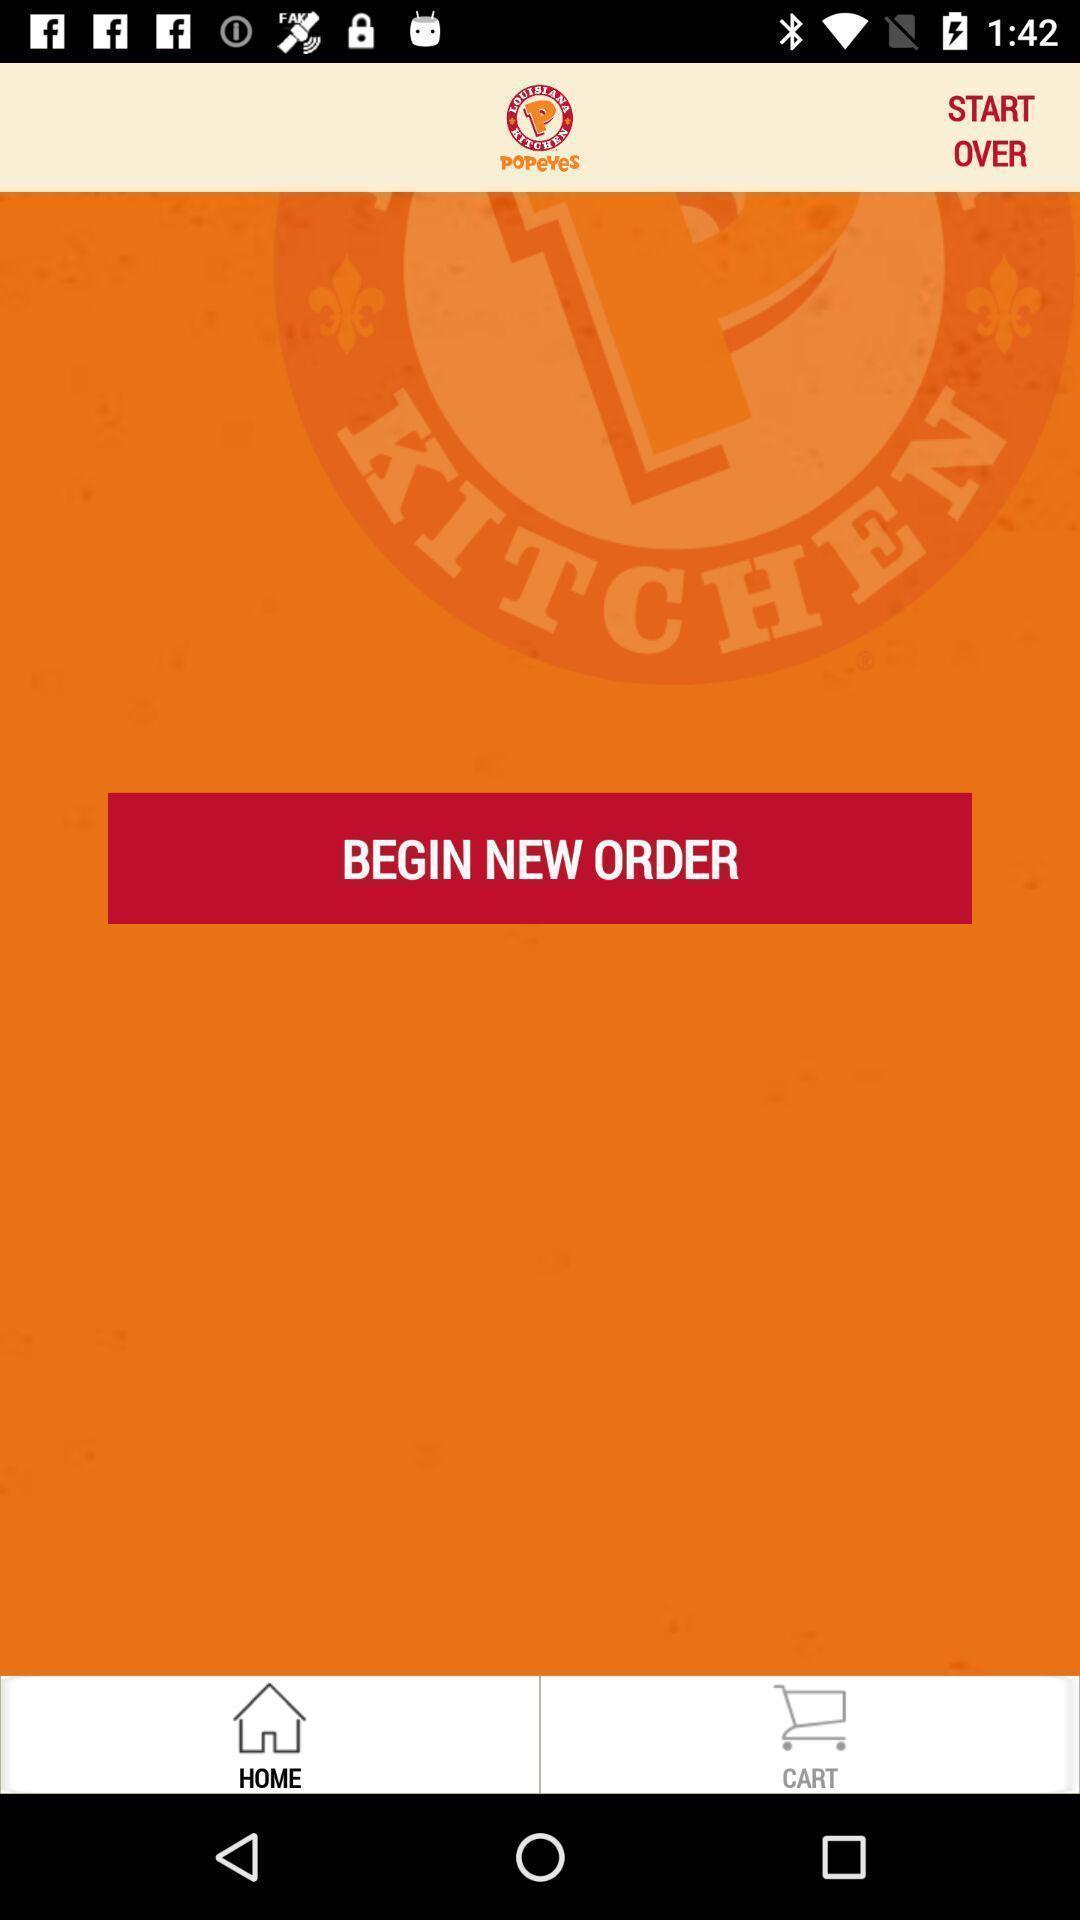Describe the key features of this screenshot. Screen displaying home page of a food app. 